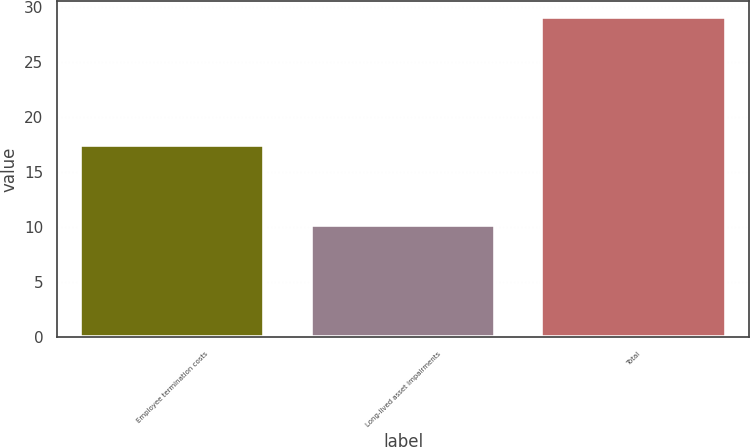Convert chart. <chart><loc_0><loc_0><loc_500><loc_500><bar_chart><fcel>Employee termination costs<fcel>Long-lived asset impairments<fcel>Total<nl><fcel>17.5<fcel>10.2<fcel>29.1<nl></chart> 